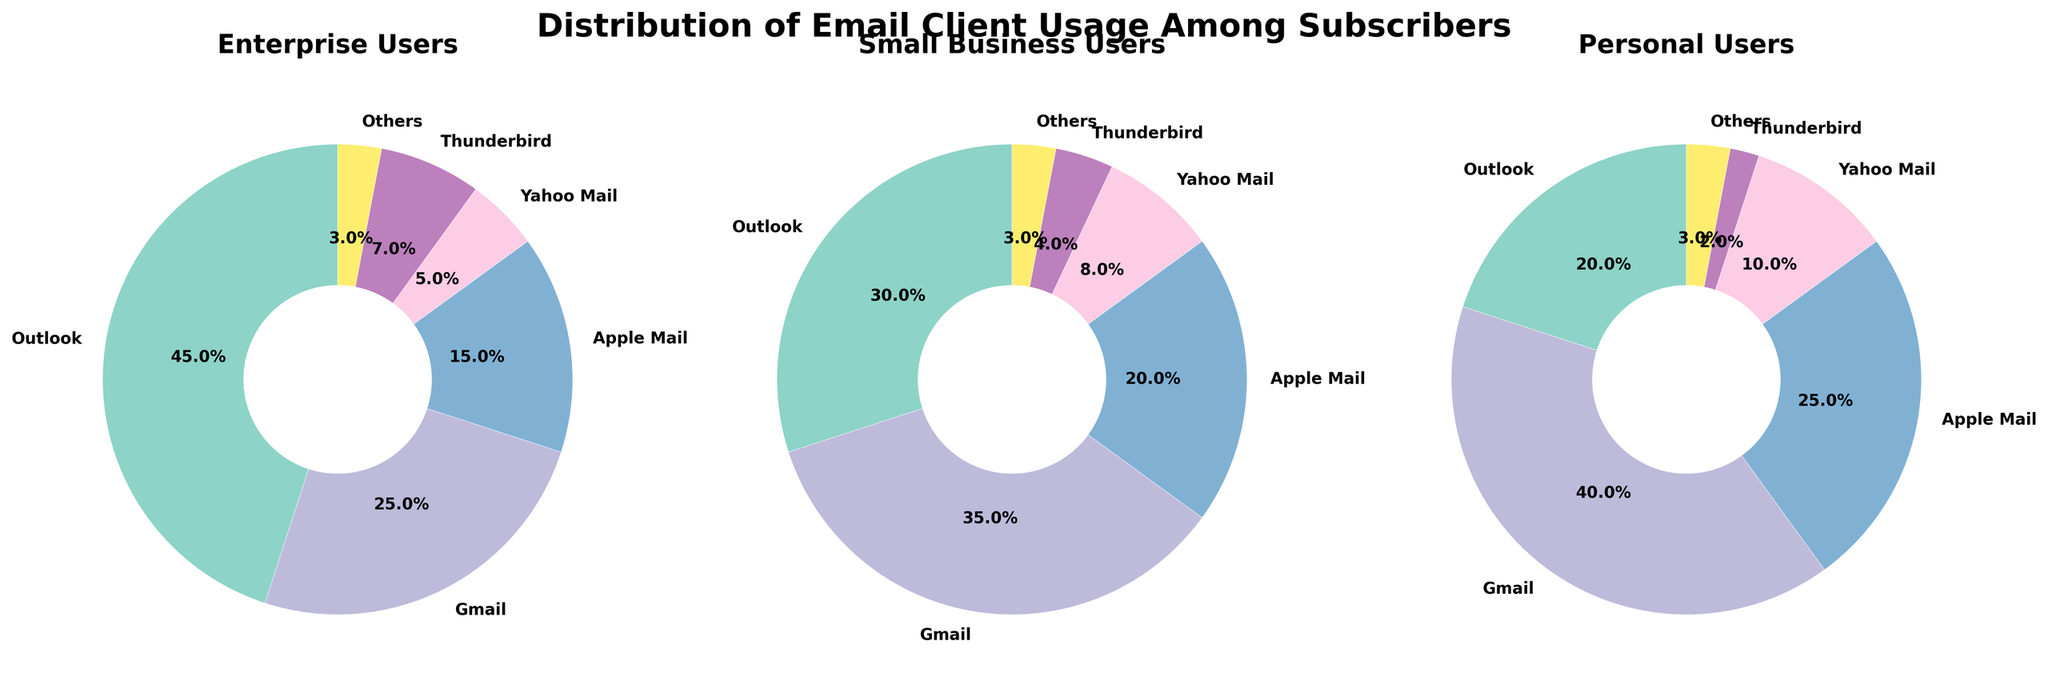What is the title of the figure? The title is usually located at the top of the figure and is written in a larger font size for visibility. Here, the title is ‘Distribution of Email Client Usage Among Subscribers’.
Answer: Distribution of Email Client Usage Among Subscribers What are the three subscriber categories shown in the pie charts? The titles above each pie chart represent the subscriber categories. The three categories are Enterprise Users, Small Business Users, and Personal Users.
Answer: Enterprise Users, Small Business Users, Personal Users Which email client has the highest usage in the Small Business Users category? In the Small Business Users category pie chart, the largest wedge corresponds to Gmail.
Answer: Gmail Which email client has the least usage among Enterprise Users? In the Enterprise Users category pie chart, the smallest wedge corresponds to Others.
Answer: Others What percentage of Personal Users use Thunderbird? In the Personal Users pie chart, the wedge for Thunderbird shows the percentage with the label '2.0%'.
Answer: 2.0% How does the percentage of Apple Mail usage compare between Enterprise Users and Personal Users? By looking at the pie charts for both categories, Personal Users have a larger Apple Mail wedge (25%) compared to Enterprise Users (15%).
Answer: Personal Users' Apple Mail usage is higher Sum the percentages of Outlook, Gmail, and Apple Mail usage in the Small Business Users category. Adding the percentages of Outlook (30%), Gmail (35%), and Apple Mail (20%) in the Small Business Users category gives 30 + 35 + 20 = 85%.
Answer: 85% Compute the average percentage usage of Outlook across all three subscriber categories. The percentages for Outlook in each category are 45% (Enterprise), 30% (Small Business), and 20% (Personal). The average is (45 + 30 + 20) / 3 = 31.67%.
Answer: 31.67% Which email client is more popular: Gmail among Personal Users or Outlook among Enterprise Users? The wedge for Gmail among Personal Users is labeled as 40%, while Outlook among Enterprise Users is 45%.
Answer: Outlook among Enterprise Users Combine the percentages of Yahoo Mail and Others usage in the Enterprise Users category and compare it to Thunderbird usage in the same category. Which is higher? Yahoo Mail and Others in Enterprise Users category sum up to 5% + 3% = 8%, which is higher than Thunderbird (7%).
Answer: Yahoo Mail + Others is higher 